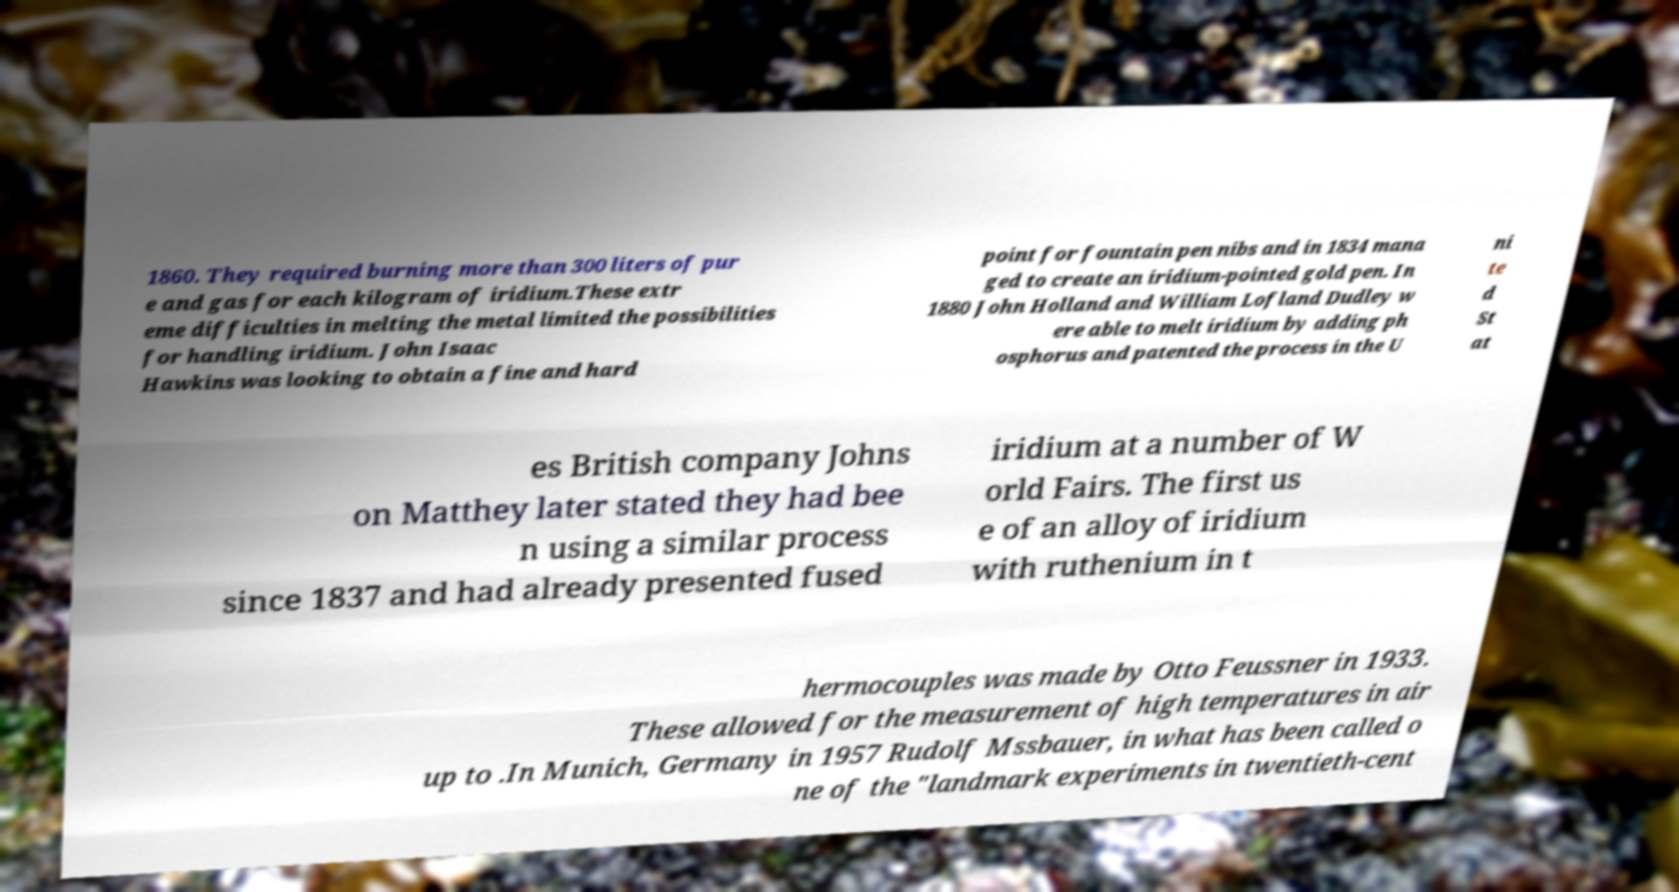What messages or text are displayed in this image? I need them in a readable, typed format. 1860. They required burning more than 300 liters of pur e and gas for each kilogram of iridium.These extr eme difficulties in melting the metal limited the possibilities for handling iridium. John Isaac Hawkins was looking to obtain a fine and hard point for fountain pen nibs and in 1834 mana ged to create an iridium-pointed gold pen. In 1880 John Holland and William Lofland Dudley w ere able to melt iridium by adding ph osphorus and patented the process in the U ni te d St at es British company Johns on Matthey later stated they had bee n using a similar process since 1837 and had already presented fused iridium at a number of W orld Fairs. The first us e of an alloy of iridium with ruthenium in t hermocouples was made by Otto Feussner in 1933. These allowed for the measurement of high temperatures in air up to .In Munich, Germany in 1957 Rudolf Mssbauer, in what has been called o ne of the "landmark experiments in twentieth-cent 